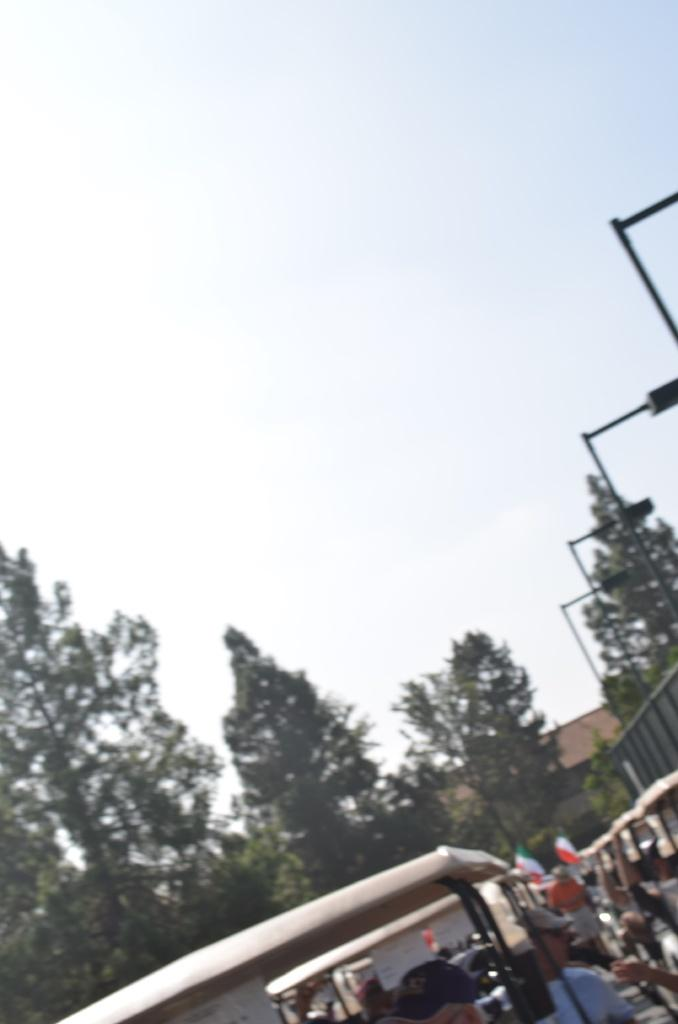What can be seen at the bottom of the image? At the bottom of the image, there are people, flags, trees, buildings, and poles. What is visible in the background of the image? The sky is visible in the background of the image. What type of poison is being used by the people in the image? There is no poison present in the image; it features people, flags, trees, buildings, and poles at the bottom, with the sky visible in the background. What are the people learning in the image? There is no indication in the image that the people are learning anything. 